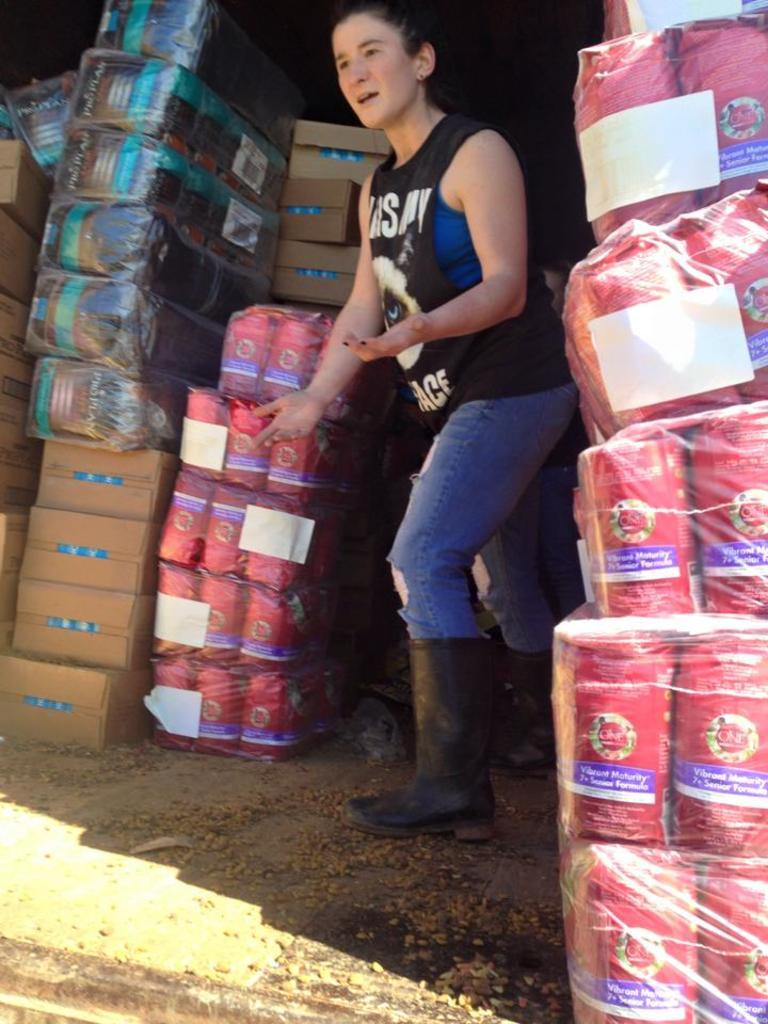What is the main subject of the image? There is a woman standing in the middle of the image. What can be seen on the left side of the image? There are bundles on the left side of the image. What is present on the right side of the image? There are boxes on the right side of the image. Is there a cellar visible in the image? There is no mention of a cellar in the provided facts, so it cannot be determined if one is present in the image. 